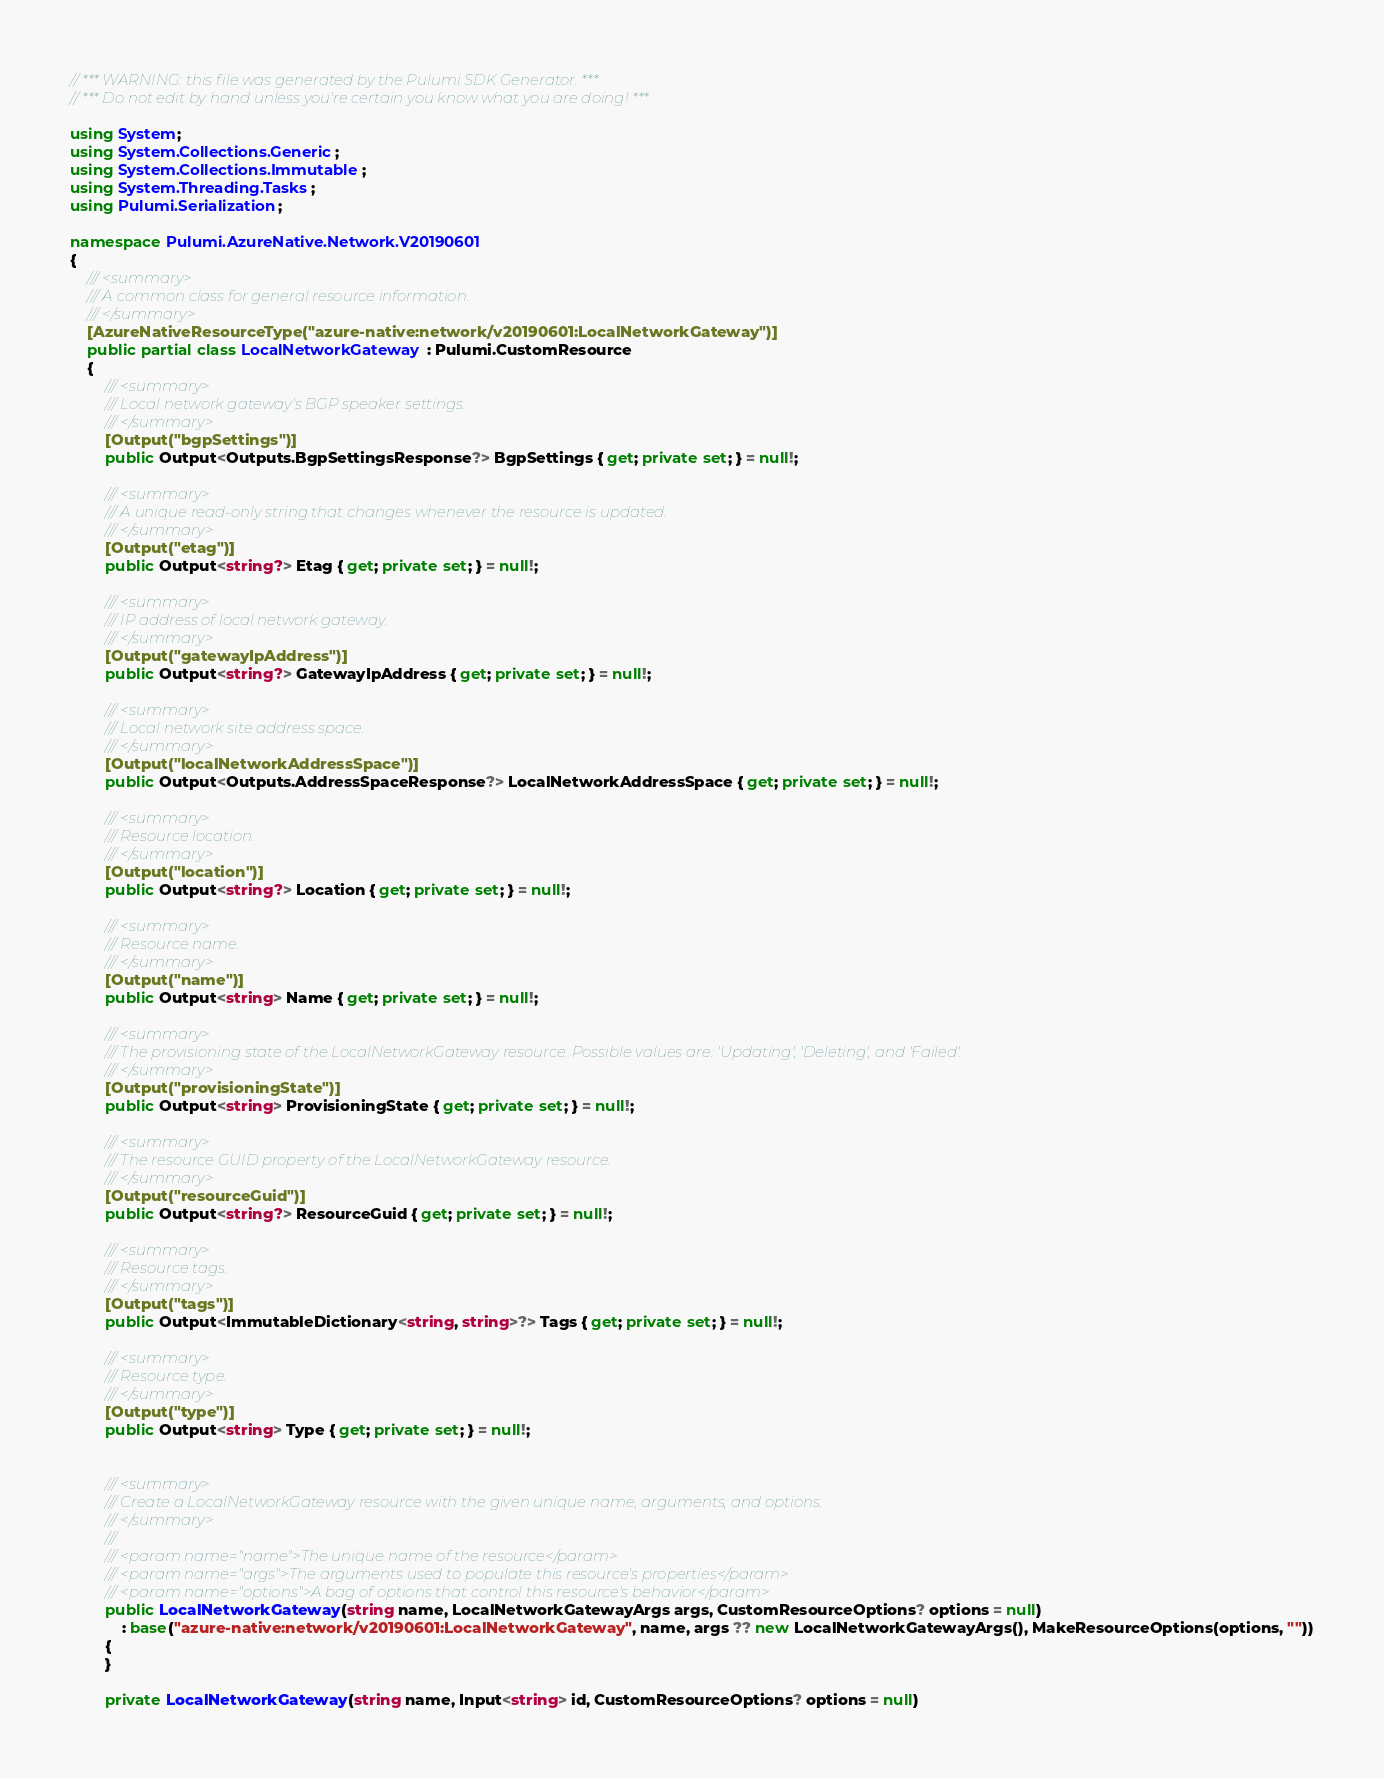<code> <loc_0><loc_0><loc_500><loc_500><_C#_>// *** WARNING: this file was generated by the Pulumi SDK Generator. ***
// *** Do not edit by hand unless you're certain you know what you are doing! ***

using System;
using System.Collections.Generic;
using System.Collections.Immutable;
using System.Threading.Tasks;
using Pulumi.Serialization;

namespace Pulumi.AzureNative.Network.V20190601
{
    /// <summary>
    /// A common class for general resource information.
    /// </summary>
    [AzureNativeResourceType("azure-native:network/v20190601:LocalNetworkGateway")]
    public partial class LocalNetworkGateway : Pulumi.CustomResource
    {
        /// <summary>
        /// Local network gateway's BGP speaker settings.
        /// </summary>
        [Output("bgpSettings")]
        public Output<Outputs.BgpSettingsResponse?> BgpSettings { get; private set; } = null!;

        /// <summary>
        /// A unique read-only string that changes whenever the resource is updated.
        /// </summary>
        [Output("etag")]
        public Output<string?> Etag { get; private set; } = null!;

        /// <summary>
        /// IP address of local network gateway.
        /// </summary>
        [Output("gatewayIpAddress")]
        public Output<string?> GatewayIpAddress { get; private set; } = null!;

        /// <summary>
        /// Local network site address space.
        /// </summary>
        [Output("localNetworkAddressSpace")]
        public Output<Outputs.AddressSpaceResponse?> LocalNetworkAddressSpace { get; private set; } = null!;

        /// <summary>
        /// Resource location.
        /// </summary>
        [Output("location")]
        public Output<string?> Location { get; private set; } = null!;

        /// <summary>
        /// Resource name.
        /// </summary>
        [Output("name")]
        public Output<string> Name { get; private set; } = null!;

        /// <summary>
        /// The provisioning state of the LocalNetworkGateway resource. Possible values are: 'Updating', 'Deleting', and 'Failed'.
        /// </summary>
        [Output("provisioningState")]
        public Output<string> ProvisioningState { get; private set; } = null!;

        /// <summary>
        /// The resource GUID property of the LocalNetworkGateway resource.
        /// </summary>
        [Output("resourceGuid")]
        public Output<string?> ResourceGuid { get; private set; } = null!;

        /// <summary>
        /// Resource tags.
        /// </summary>
        [Output("tags")]
        public Output<ImmutableDictionary<string, string>?> Tags { get; private set; } = null!;

        /// <summary>
        /// Resource type.
        /// </summary>
        [Output("type")]
        public Output<string> Type { get; private set; } = null!;


        /// <summary>
        /// Create a LocalNetworkGateway resource with the given unique name, arguments, and options.
        /// </summary>
        ///
        /// <param name="name">The unique name of the resource</param>
        /// <param name="args">The arguments used to populate this resource's properties</param>
        /// <param name="options">A bag of options that control this resource's behavior</param>
        public LocalNetworkGateway(string name, LocalNetworkGatewayArgs args, CustomResourceOptions? options = null)
            : base("azure-native:network/v20190601:LocalNetworkGateway", name, args ?? new LocalNetworkGatewayArgs(), MakeResourceOptions(options, ""))
        {
        }

        private LocalNetworkGateway(string name, Input<string> id, CustomResourceOptions? options = null)</code> 